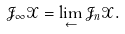Convert formula to latex. <formula><loc_0><loc_0><loc_500><loc_500>\mathcal { J } _ { \infty } \mathcal { X } = \lim _ { \leftarrow } \mathcal { J } _ { n } \mathcal { X } .</formula> 